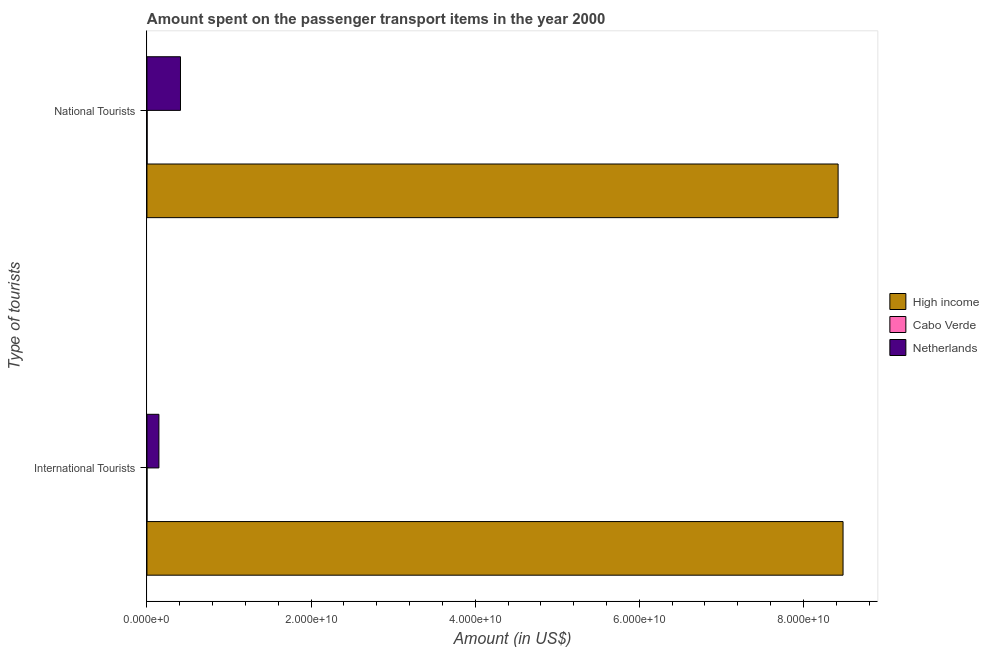Are the number of bars on each tick of the Y-axis equal?
Make the answer very short. Yes. How many bars are there on the 2nd tick from the bottom?
Your answer should be compact. 3. What is the label of the 2nd group of bars from the top?
Keep it short and to the point. International Tourists. What is the amount spent on transport items of national tourists in High income?
Offer a terse response. 8.42e+1. Across all countries, what is the maximum amount spent on transport items of international tourists?
Ensure brevity in your answer.  8.48e+1. Across all countries, what is the minimum amount spent on transport items of national tourists?
Provide a succinct answer. 2.30e+07. In which country was the amount spent on transport items of national tourists minimum?
Ensure brevity in your answer.  Cabo Verde. What is the total amount spent on transport items of national tourists in the graph?
Provide a succinct answer. 8.83e+1. What is the difference between the amount spent on transport items of national tourists in Netherlands and that in Cabo Verde?
Make the answer very short. 4.06e+09. What is the difference between the amount spent on transport items of international tourists in Netherlands and the amount spent on transport items of national tourists in Cabo Verde?
Ensure brevity in your answer.  1.44e+09. What is the average amount spent on transport items of international tourists per country?
Your answer should be very brief. 2.88e+1. What is the difference between the amount spent on transport items of international tourists and amount spent on transport items of national tourists in High income?
Give a very brief answer. 6.02e+08. In how many countries, is the amount spent on transport items of national tourists greater than 52000000000 US$?
Offer a terse response. 1. What is the ratio of the amount spent on transport items of international tourists in Netherlands to that in High income?
Make the answer very short. 0.02. What does the 2nd bar from the top in International Tourists represents?
Offer a very short reply. Cabo Verde. What does the 2nd bar from the bottom in National Tourists represents?
Make the answer very short. Cabo Verde. How many bars are there?
Your answer should be compact. 6. Are the values on the major ticks of X-axis written in scientific E-notation?
Ensure brevity in your answer.  Yes. Does the graph contain grids?
Give a very brief answer. No. Where does the legend appear in the graph?
Offer a very short reply. Center right. How are the legend labels stacked?
Your response must be concise. Vertical. What is the title of the graph?
Your answer should be very brief. Amount spent on the passenger transport items in the year 2000. What is the label or title of the Y-axis?
Keep it short and to the point. Type of tourists. What is the Amount (in US$) of High income in International Tourists?
Provide a succinct answer. 8.48e+1. What is the Amount (in US$) in Netherlands in International Tourists?
Provide a short and direct response. 1.46e+09. What is the Amount (in US$) in High income in National Tourists?
Provide a succinct answer. 8.42e+1. What is the Amount (in US$) in Cabo Verde in National Tourists?
Ensure brevity in your answer.  2.30e+07. What is the Amount (in US$) of Netherlands in National Tourists?
Provide a succinct answer. 4.09e+09. Across all Type of tourists, what is the maximum Amount (in US$) of High income?
Your answer should be very brief. 8.48e+1. Across all Type of tourists, what is the maximum Amount (in US$) in Cabo Verde?
Offer a terse response. 2.30e+07. Across all Type of tourists, what is the maximum Amount (in US$) in Netherlands?
Keep it short and to the point. 4.09e+09. Across all Type of tourists, what is the minimum Amount (in US$) of High income?
Keep it short and to the point. 8.42e+1. Across all Type of tourists, what is the minimum Amount (in US$) in Netherlands?
Keep it short and to the point. 1.46e+09. What is the total Amount (in US$) of High income in the graph?
Offer a terse response. 1.69e+11. What is the total Amount (in US$) of Cabo Verde in the graph?
Offer a terse response. 2.80e+07. What is the total Amount (in US$) in Netherlands in the graph?
Your response must be concise. 5.55e+09. What is the difference between the Amount (in US$) in High income in International Tourists and that in National Tourists?
Your answer should be compact. 6.02e+08. What is the difference between the Amount (in US$) in Cabo Verde in International Tourists and that in National Tourists?
Give a very brief answer. -1.80e+07. What is the difference between the Amount (in US$) in Netherlands in International Tourists and that in National Tourists?
Give a very brief answer. -2.63e+09. What is the difference between the Amount (in US$) of High income in International Tourists and the Amount (in US$) of Cabo Verde in National Tourists?
Keep it short and to the point. 8.48e+1. What is the difference between the Amount (in US$) in High income in International Tourists and the Amount (in US$) in Netherlands in National Tourists?
Your answer should be compact. 8.07e+1. What is the difference between the Amount (in US$) in Cabo Verde in International Tourists and the Amount (in US$) in Netherlands in National Tourists?
Offer a very short reply. -4.08e+09. What is the average Amount (in US$) of High income per Type of tourists?
Offer a terse response. 8.45e+1. What is the average Amount (in US$) of Cabo Verde per Type of tourists?
Your answer should be very brief. 1.40e+07. What is the average Amount (in US$) of Netherlands per Type of tourists?
Ensure brevity in your answer.  2.77e+09. What is the difference between the Amount (in US$) in High income and Amount (in US$) in Cabo Verde in International Tourists?
Your answer should be compact. 8.48e+1. What is the difference between the Amount (in US$) in High income and Amount (in US$) in Netherlands in International Tourists?
Provide a short and direct response. 8.34e+1. What is the difference between the Amount (in US$) of Cabo Verde and Amount (in US$) of Netherlands in International Tourists?
Your answer should be very brief. -1.45e+09. What is the difference between the Amount (in US$) in High income and Amount (in US$) in Cabo Verde in National Tourists?
Provide a short and direct response. 8.42e+1. What is the difference between the Amount (in US$) in High income and Amount (in US$) in Netherlands in National Tourists?
Your answer should be compact. 8.01e+1. What is the difference between the Amount (in US$) of Cabo Verde and Amount (in US$) of Netherlands in National Tourists?
Offer a very short reply. -4.06e+09. What is the ratio of the Amount (in US$) of High income in International Tourists to that in National Tourists?
Ensure brevity in your answer.  1.01. What is the ratio of the Amount (in US$) of Cabo Verde in International Tourists to that in National Tourists?
Make the answer very short. 0.22. What is the ratio of the Amount (in US$) of Netherlands in International Tourists to that in National Tourists?
Offer a terse response. 0.36. What is the difference between the highest and the second highest Amount (in US$) of High income?
Offer a terse response. 6.02e+08. What is the difference between the highest and the second highest Amount (in US$) of Cabo Verde?
Give a very brief answer. 1.80e+07. What is the difference between the highest and the second highest Amount (in US$) of Netherlands?
Offer a terse response. 2.63e+09. What is the difference between the highest and the lowest Amount (in US$) of High income?
Offer a very short reply. 6.02e+08. What is the difference between the highest and the lowest Amount (in US$) of Cabo Verde?
Keep it short and to the point. 1.80e+07. What is the difference between the highest and the lowest Amount (in US$) of Netherlands?
Offer a terse response. 2.63e+09. 